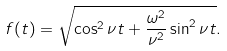Convert formula to latex. <formula><loc_0><loc_0><loc_500><loc_500>f ( t ) = \sqrt { \cos ^ { 2 } \nu t + \frac { \omega ^ { 2 } } { \nu ^ { 2 } } \sin ^ { 2 } \nu t } .</formula> 